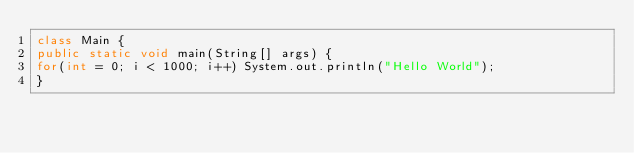<code> <loc_0><loc_0><loc_500><loc_500><_Java_>class Main {
public static void main(String[] args) {
for(int = 0; i < 1000; i++) System.out.println("Hello World");
}</code> 